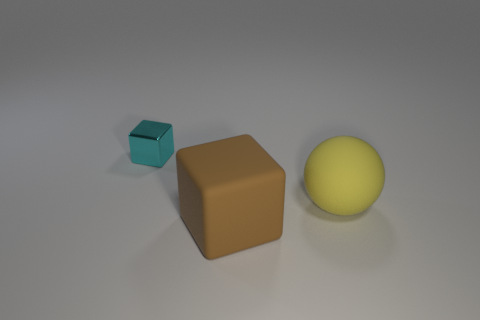Add 3 tiny purple metallic blocks. How many objects exist? 6 Subtract all blocks. How many objects are left? 1 Add 1 big blue matte balls. How many big blue matte balls exist? 1 Subtract 0 cyan spheres. How many objects are left? 3 Subtract all brown metallic balls. Subtract all brown blocks. How many objects are left? 2 Add 3 big brown cubes. How many big brown cubes are left? 4 